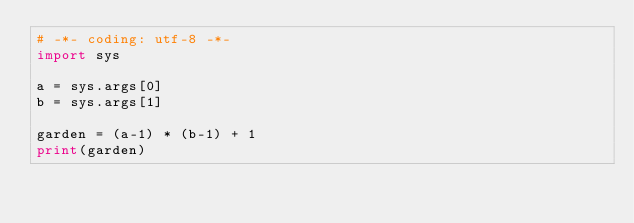Convert code to text. <code><loc_0><loc_0><loc_500><loc_500><_Python_># -*- coding: utf-8 -*-
import sys

a = sys.args[0]
b = sys.args[1]

garden = (a-1) * (b-1) + 1
print(garden)
</code> 